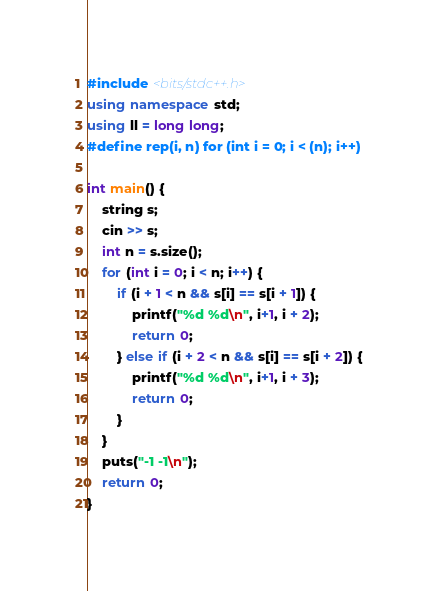Convert code to text. <code><loc_0><loc_0><loc_500><loc_500><_C++_>#include <bits/stdc++.h>
using namespace std;
using ll = long long;
#define rep(i, n) for (int i = 0; i < (n); i++)

int main() {
    string s;
    cin >> s;
    int n = s.size();
    for (int i = 0; i < n; i++) {
        if (i + 1 < n && s[i] == s[i + 1]) {
            printf("%d %d\n", i+1, i + 2);
            return 0;
        } else if (i + 2 < n && s[i] == s[i + 2]) {
            printf("%d %d\n", i+1, i + 3);
            return 0;
        }
    }
    puts("-1 -1\n");
    return 0;
}</code> 